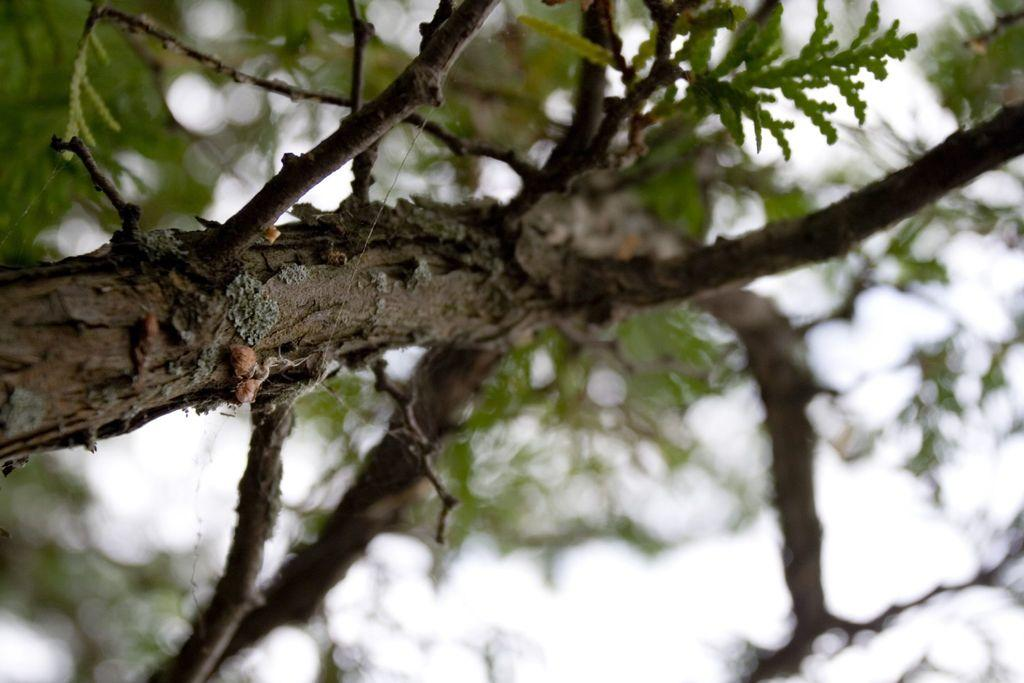What type of plant can be seen in the image? There is a tree in the image. What part of the natural environment is visible in the image? The sky is visible in the image. Where can the honey be found in the image? There is no honey present in the image. What type of sport is being played in the image? There is no sport or volleyball present in the image. 